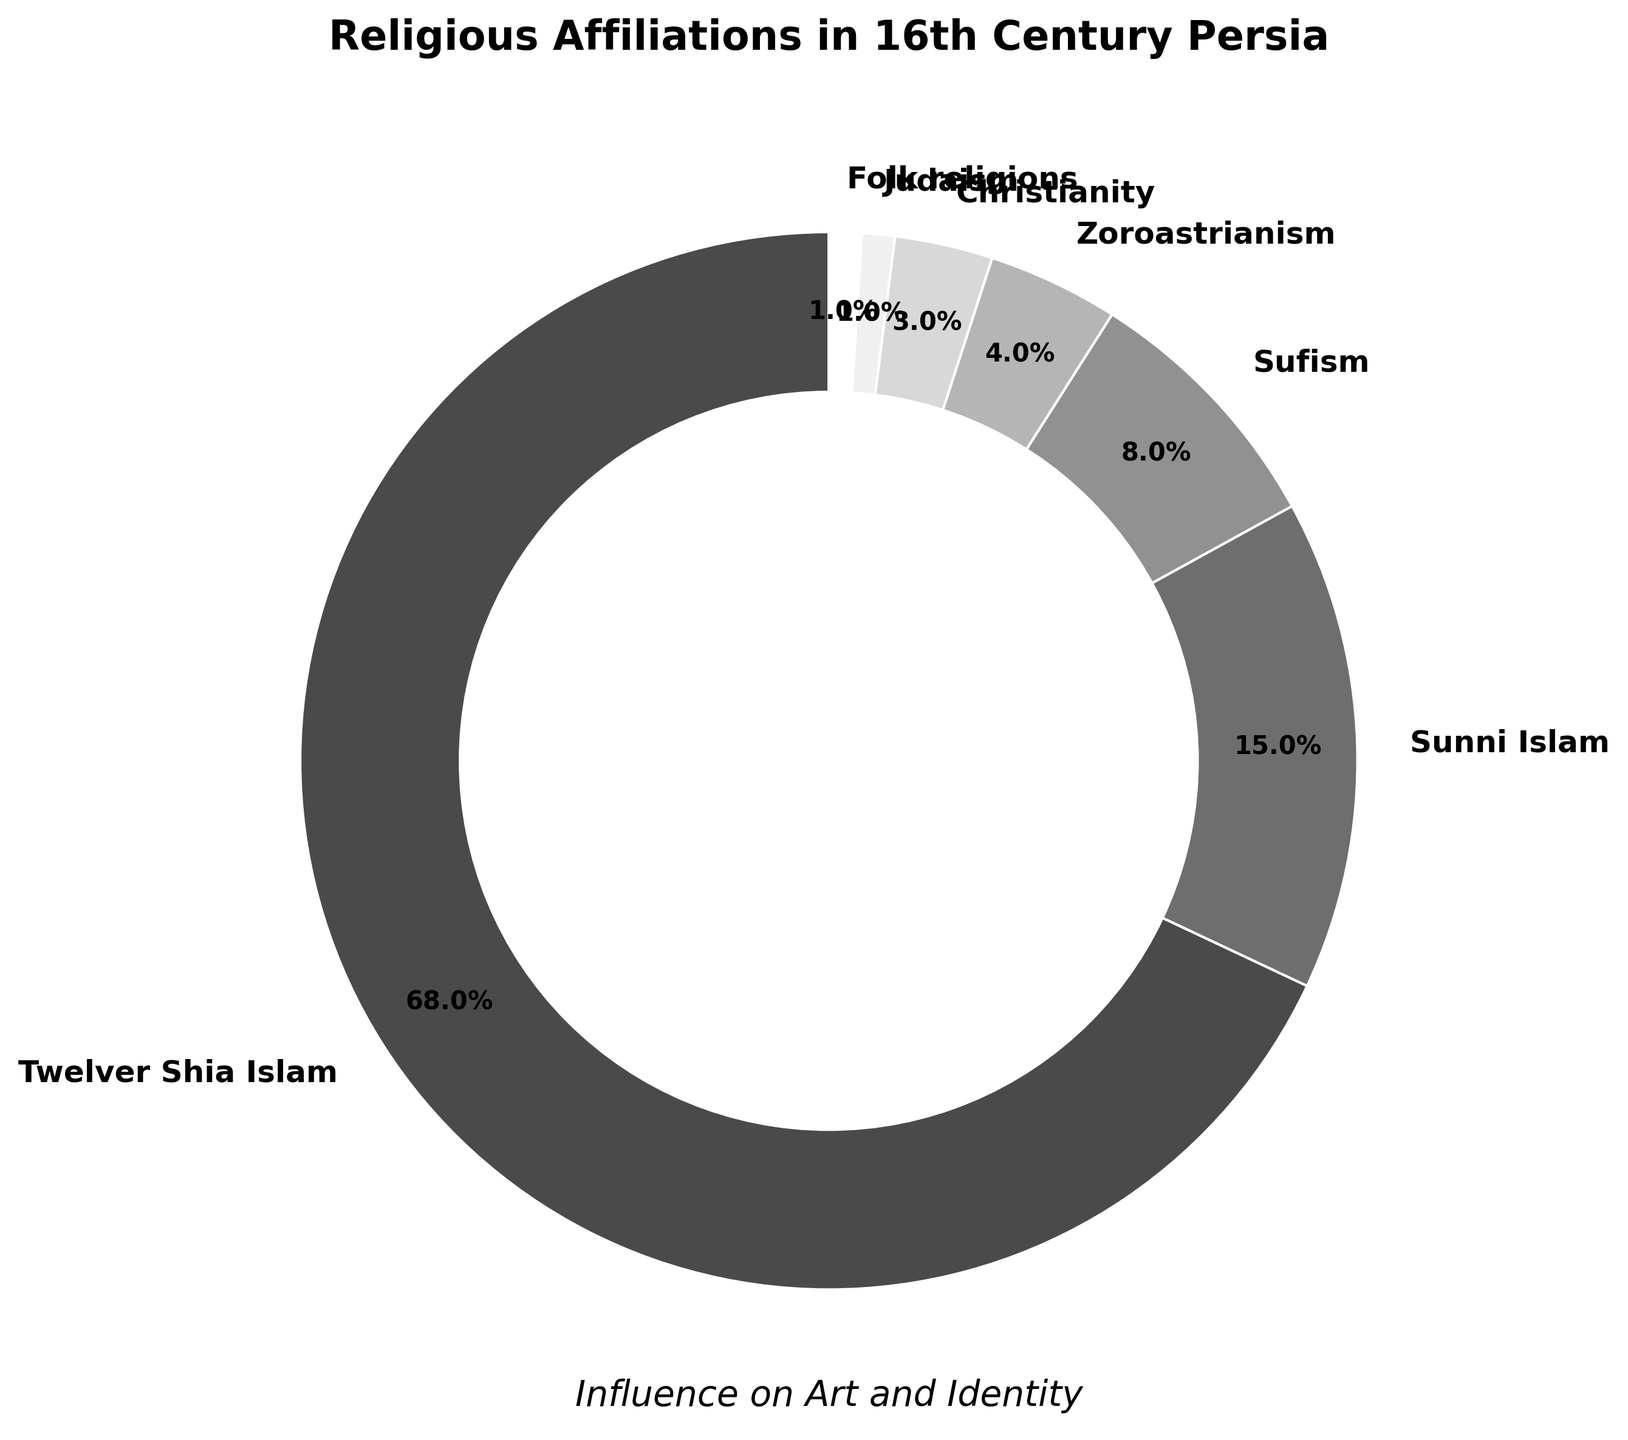What is the largest religious affiliation shown in the pie chart? The pie chart shows different religious affiliations with varying sizes. By observing the largest segment, it clearly represents Twelver Shia Islam.
Answer: Twelver Shia Islam Which two religious affiliations combined have a percentage close to 20%? We need to identify two religious affiliations whose combined percentages are approximately equal to 20%. From the data, Sufism (8%) and Sunni Islam (15%) combine to 23%, which is close to 20%.
Answer: Sufism and Sunni Islam By what percentage does Twelver Shia Islam exceed Sunni Islam in the chart? Check the percentages for Twelver Shia Islam and Sunni Islam. Twelver Shia Islam is 68%, and Sunni Islam is 15%. Subtract the percentage of Sunni Islam from Twelver Shia Islam: 68% - 15% = 53%.
Answer: 53% What percentage is represented by the smallest religious affiliations together? Identify the least represented religions on the pie chart: Judaism (1%) and Folk religions (1%). Add their percentages: 1% + 1% = 2%.
Answer: 2% Are there more followers of Sufism or Christianity according to the chart? Compare the percentages of Sufism and Christianity. Sufism has 8%, and Christianity has 3%. Clearly, Sufism has more followers.
Answer: Sufism Which religions have equal representation, and what is their percentage? Look for segments on the pie chart that share the same percentage value. Folk religions and Judaism both have 1%.
Answer: Folk religions and Judaism, 1% How many percentage points are there between the second most common and the third most common religions? Identify the second and third most common religions: Sunni Islam (15%) and Sufism (8%). Subtract the percentage of Sufism from Sunni Islam: 15% - 8% = 7%.
Answer: 7% Which religious affiliation followed by Sufism amounts to one-fourth of the total shown on the chart? First, determine 25% of the total (which is 25%). Sufism has 8%, so find the next affiliation whose total with Sufism is close to 25%; Zoroastrianism (4%) results in 8% + 4% = 12%, however, Christianity (3%) results in 8% + 3% = 11%. Combine Sufism (8%) and Sunni Islam (15%): 8% + 15% = 23%.
Answer: Sunni Islam Which segment is the lightest in color according to the pie chart, and what is its percentage? In grayscale styling, the lighter colors typically represent the segments with lower percentages. According to the chart, Folk religions at 1% and Judaism at 1% are the lightest.
Answer: Folk religions and Judaism, 1% 